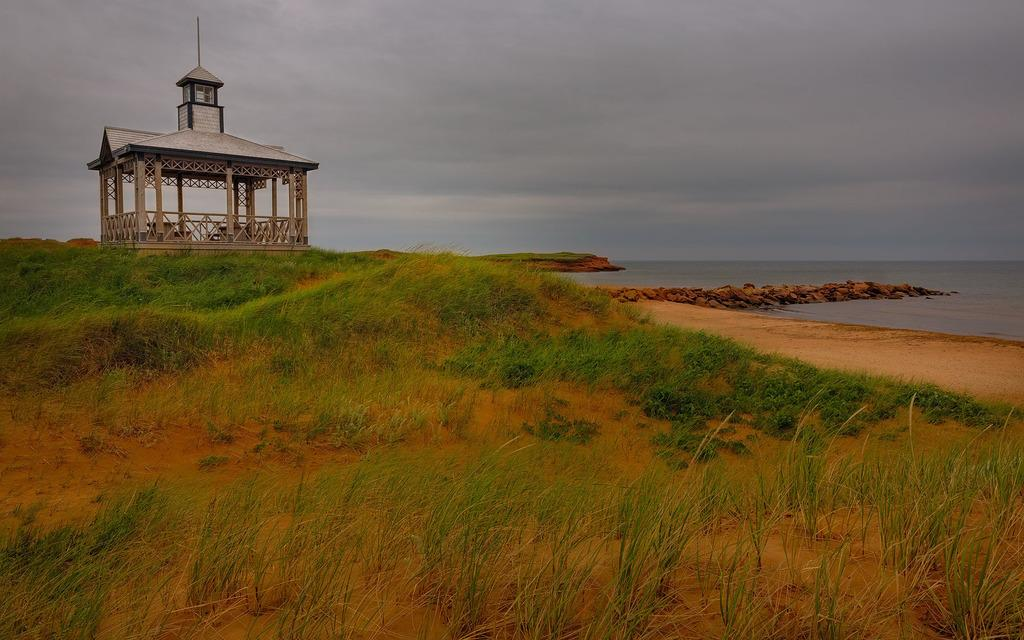What type of structure is present in the image? There is a shed in the image. What is the ground surface like in the image? The ground in the image is covered with grass. Can you see any large body of water in the image? Yes, there is a sea visible in the bottom right corner of the image. What color are the toes of the person standing near the shed? There are no people or toes visible in the image; it only shows a shed and grass-covered ground. 